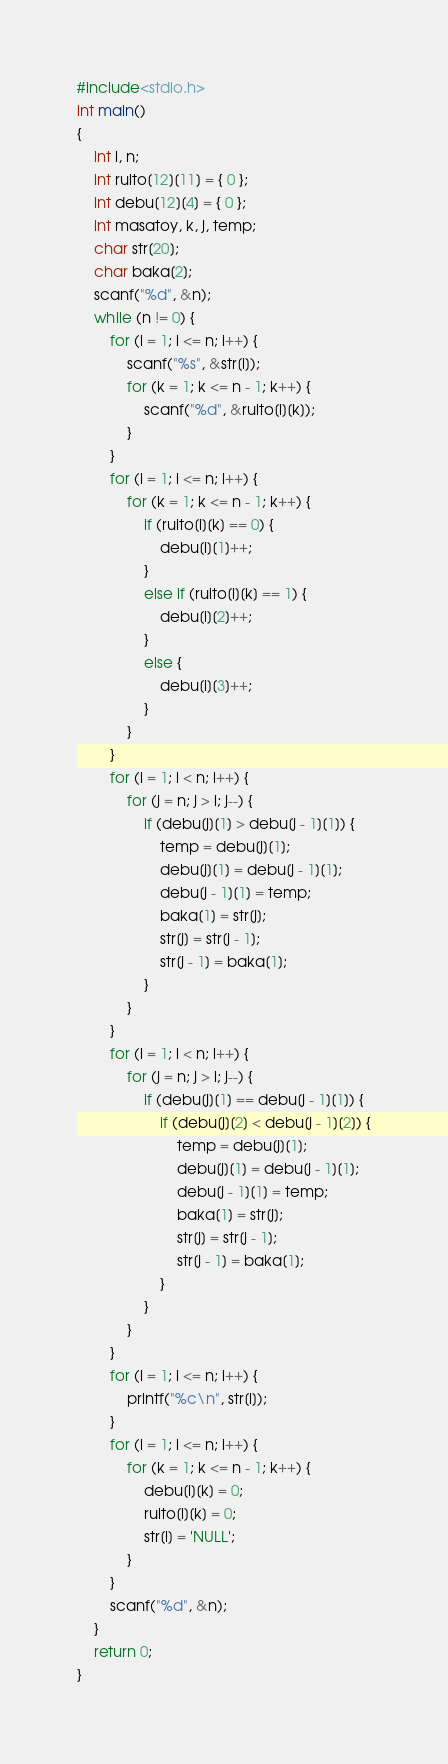<code> <loc_0><loc_0><loc_500><loc_500><_C_>#include<stdio.h>
int main()
{
	int i, n;
	int ruito[12][11] = { 0 };
	int debu[12][4] = { 0 };
	int masatoy, k, j, temp;
	char str[20];
	char baka[2];
	scanf("%d", &n);
	while (n != 0) {
		for (i = 1; i <= n; i++) {
			scanf("%s", &str[i]);
			for (k = 1; k <= n - 1; k++) {
				scanf("%d", &ruito[i][k]);
			}
		}
		for (i = 1; i <= n; i++) {
			for (k = 1; k <= n - 1; k++) {
				if (ruito[i][k] == 0) {
					debu[i][1]++;
				}
				else if (ruito[i][k] == 1) {
					debu[i][2]++;
				}
				else {
					debu[i][3]++;
				}
			}
		}
		for (i = 1; i < n; i++) {
			for (j = n; j > i; j--) {
				if (debu[j][1] > debu[j - 1][1]) {
					temp = debu[j][1];
					debu[j][1] = debu[j - 1][1];
					debu[j - 1][1] = temp;
					baka[1] = str[j];
					str[j] = str[j - 1];
					str[j - 1] = baka[1];
				}
			}
		}
		for (i = 1; i < n; i++) {
			for (j = n; j > i; j--) {
				if (debu[j][1] == debu[j - 1][1]) {
					if (debu[j][2] < debu[j - 1][2]) {
						temp = debu[j][1];
						debu[j][1] = debu[j - 1][1];
						debu[j - 1][1] = temp;
						baka[1] = str[j];
						str[j] = str[j - 1];
						str[j - 1] = baka[1];
					}
				}
			}
		}
		for (i = 1; i <= n; i++) {
			printf("%c\n", str[i]);
		}
		for (i = 1; i <= n; i++) {
			for (k = 1; k <= n - 1; k++) {
				debu[i][k] = 0;
				ruito[i][k] = 0;
				str[i] = 'NULL';
			}
		}
		scanf("%d", &n);
	}
	return 0;
}</code> 